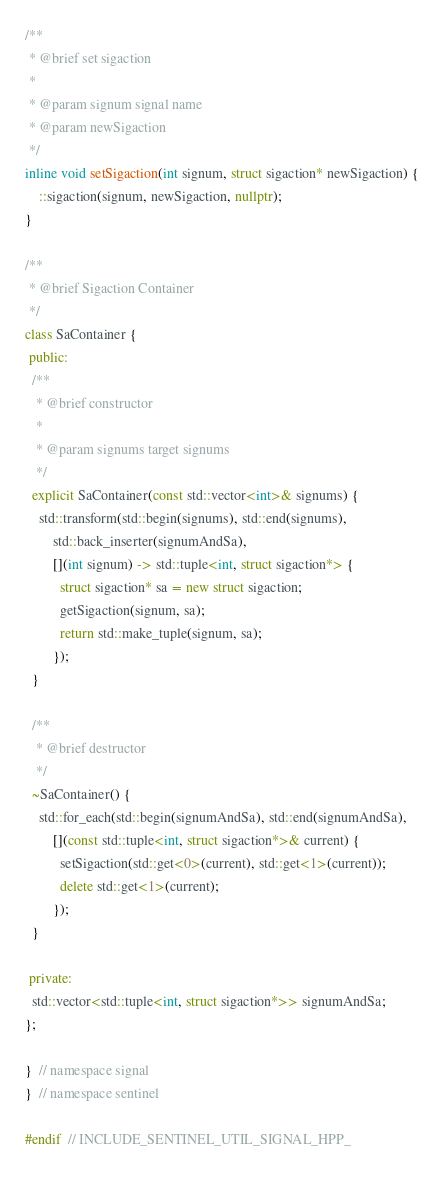<code> <loc_0><loc_0><loc_500><loc_500><_C++_>/**
 * @brief set sigaction
 *
 * @param signum signal name
 * @param newSigaction
 */
inline void setSigaction(int signum, struct sigaction* newSigaction) {
    ::sigaction(signum, newSigaction, nullptr);
}

/**
 * @brief Sigaction Container
 */
class SaContainer {
 public:
  /**
   * @brief constructor
   *
   * @param signums target signums
   */
  explicit SaContainer(const std::vector<int>& signums) {
    std::transform(std::begin(signums), std::end(signums),
        std::back_inserter(signumAndSa),
        [](int signum) -> std::tuple<int, struct sigaction*> {
          struct sigaction* sa = new struct sigaction;
          getSigaction(signum, sa);
          return std::make_tuple(signum, sa);
        });
  }

  /**
   * @brief destructor
   */
  ~SaContainer() {
    std::for_each(std::begin(signumAndSa), std::end(signumAndSa),
        [](const std::tuple<int, struct sigaction*>& current) {
          setSigaction(std::get<0>(current), std::get<1>(current));
          delete std::get<1>(current);
        });
  }

 private:
  std::vector<std::tuple<int, struct sigaction*>> signumAndSa;
};

}  // namespace signal
}  // namespace sentinel

#endif  // INCLUDE_SENTINEL_UTIL_SIGNAL_HPP_
</code> 